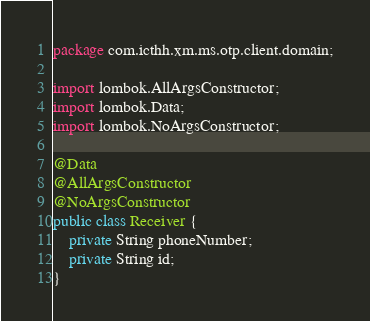Convert code to text. <code><loc_0><loc_0><loc_500><loc_500><_Java_>package com.icthh.xm.ms.otp.client.domain;

import lombok.AllArgsConstructor;
import lombok.Data;
import lombok.NoArgsConstructor;

@Data
@AllArgsConstructor
@NoArgsConstructor
public class Receiver {
    private String phoneNumber;
    private String id;
}
</code> 